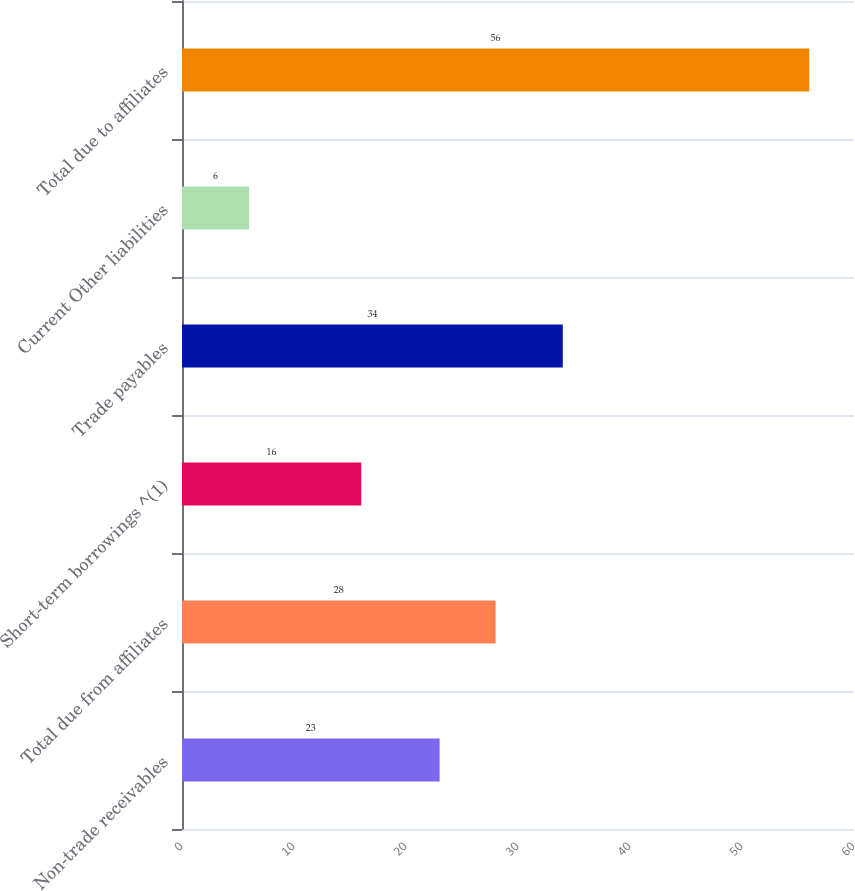Convert chart. <chart><loc_0><loc_0><loc_500><loc_500><bar_chart><fcel>Non-trade receivables<fcel>Total due from affiliates<fcel>Short-term borrowings ^(1)<fcel>Trade payables<fcel>Current Other liabilities<fcel>Total due to affiliates<nl><fcel>23<fcel>28<fcel>16<fcel>34<fcel>6<fcel>56<nl></chart> 